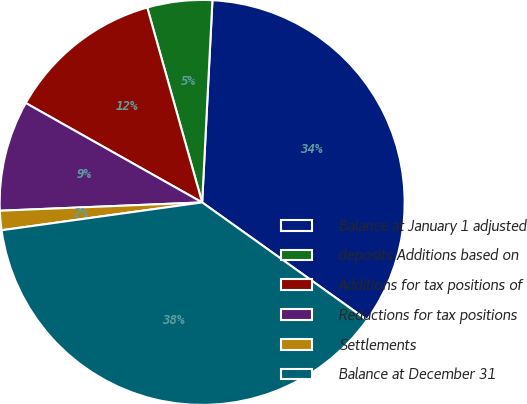Convert chart to OTSL. <chart><loc_0><loc_0><loc_500><loc_500><pie_chart><fcel>Balance at January 1 adjusted<fcel>deposits Additions based on<fcel>Additions for tax positions of<fcel>Reductions for tax positions<fcel>Settlements<fcel>Balance at December 31<nl><fcel>34.05%<fcel>5.18%<fcel>12.46%<fcel>8.82%<fcel>1.54%<fcel>37.94%<nl></chart> 